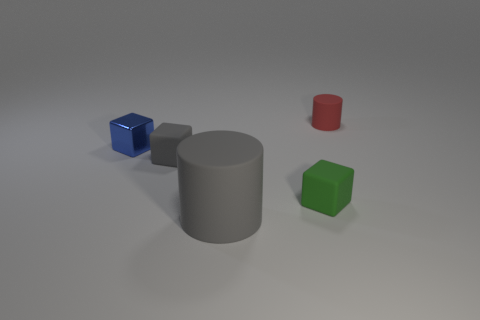What can you tell me about the lighting and shadows in this scene? The scene is softly lit from above, creating gentle shadows that fall to the right of the objects, suggesting a single diffuse light source. Does the lighting reveal anything about the texture of the surfaces? Yes, the lighting accentuates the smoothness of the objects' surfaces, and the subtle differences in texture can be seen by how they reflect light differently. 